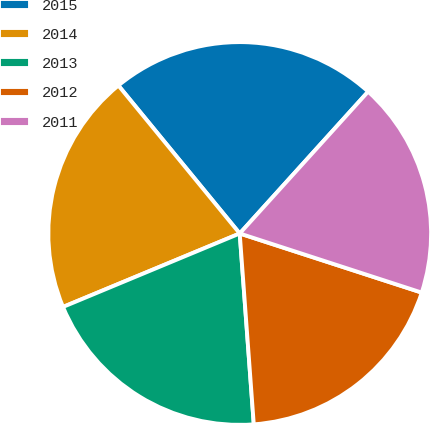Convert chart. <chart><loc_0><loc_0><loc_500><loc_500><pie_chart><fcel>2015<fcel>2014<fcel>2013<fcel>2012<fcel>2011<nl><fcel>22.64%<fcel>20.34%<fcel>19.9%<fcel>18.83%<fcel>18.29%<nl></chart> 